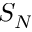Convert formula to latex. <formula><loc_0><loc_0><loc_500><loc_500>S _ { N }</formula> 